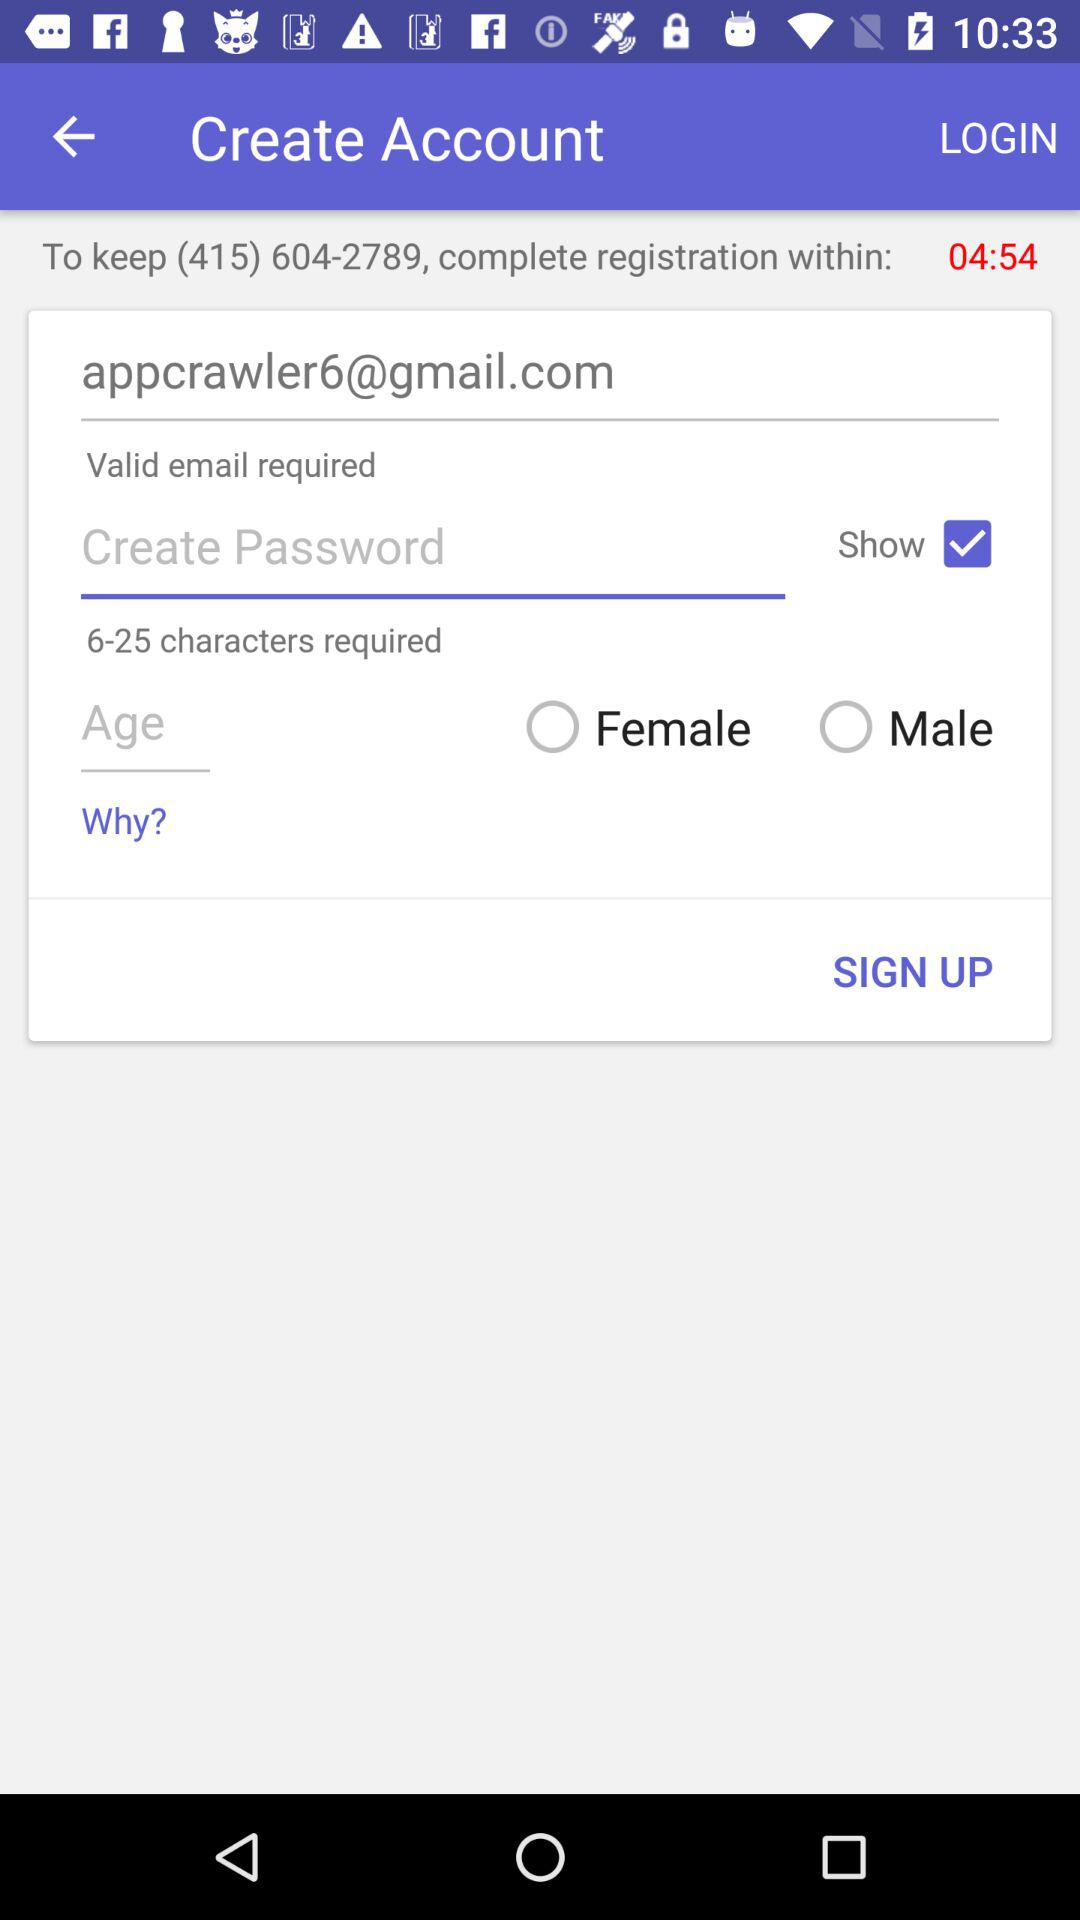What is the email address?
When the provided information is insufficient, respond with <no answer>. <no answer> 